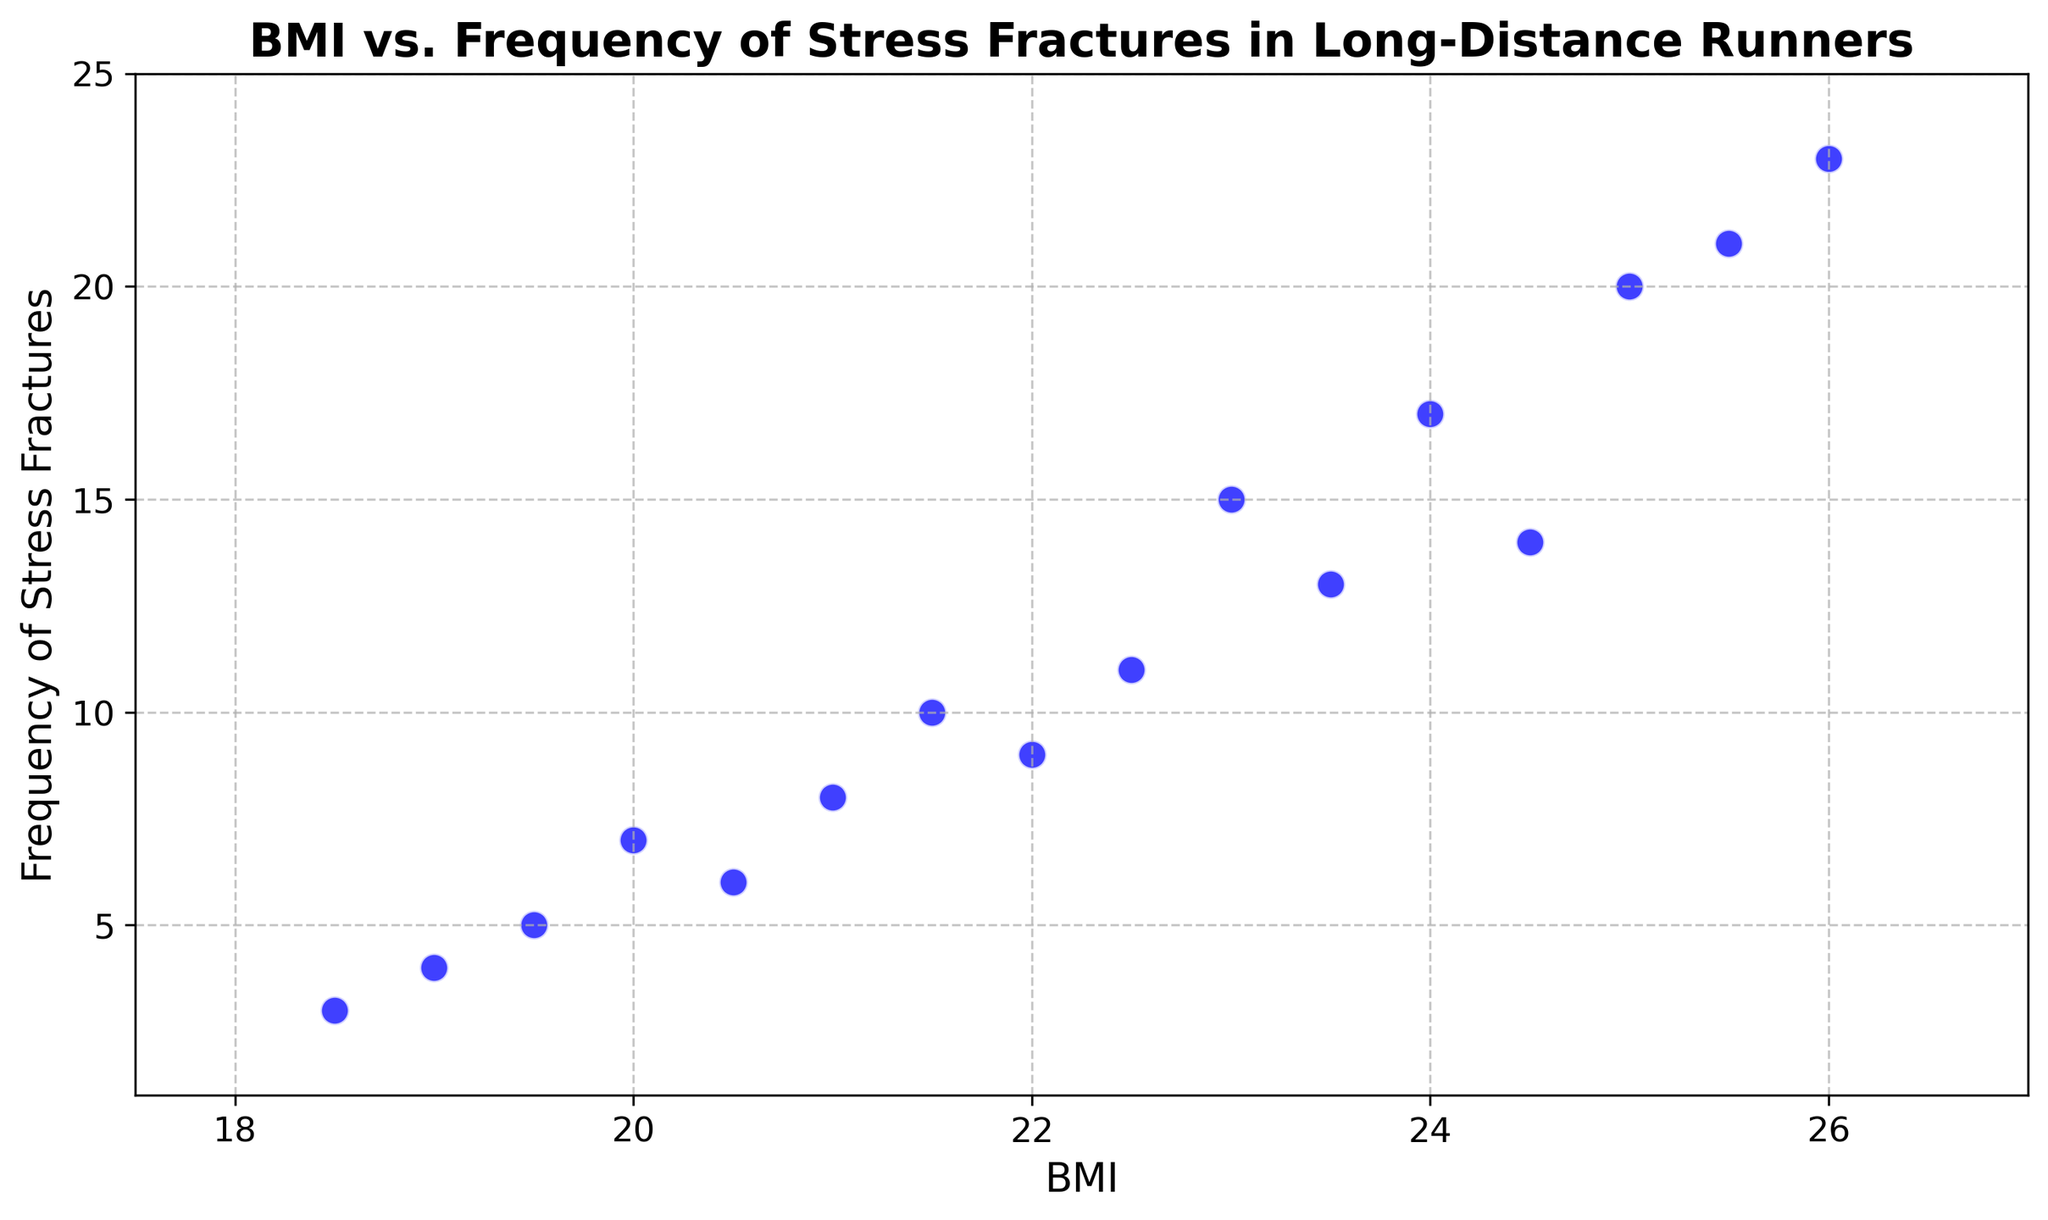What range of BMI values does the figure cover? The x-axis, labeled "BMI," shows values starting at 17.5 and ending at 27, which indicates the range of BMI values covered in the scatter plot.
Answer: 17.5 to 27 At what BMI is the frequency of stress fractures highest? By examining where the scatter points reach their maximum vertical position on the y-axis, labeled "Frequency of Stress Fractures," it can be seen that the highest frequency of stress fractures occurs at a BMI of 26 with a frequency of 23.
Answer: 26 How does the frequency of stress fractures change as BMI increases from 18.5 to 25.5? By following the scatter points from a BMI of 18.5 to 25.5 on the x-axis and noting the y-values, it can be observed that the frequency of stress fractures generally increases as BMI increases, with some fluctuations.
Answer: It generally increases What is the average frequency of stress fractures for BMIs between 20 and 22 (inclusive)? The points for BMIs 20, 20.5, 21, and 22 show frequencies of 7, 6, 8, and 9 respectively. Adding these values gives 7 + 6 + 8 + 9 = 30. There are 4 data points, so the average is 30/4 = 7.5.
Answer: 7.5 Is there any notable trend in the relationship between BMI and stress fractures? By observing the pattern of scatter points from left to right across the figure, it can be noted that as BMI increases, the frequency of stress fractures generally increases, suggesting a positive correlation.
Answer: Positive correlation Which BMI has the least frequency of stress fractures, and what is its value? The scatter point with the lowest position on the y-axis corresponds to the BMI of 18.5, which has a value of 3.
Answer: 18.5, 3 What is the total frequency of stress fractures for BMIs above 24 inclusive? For BMIs 24, 24.5, 25, 25.5, and 26, the frequencies are 17, 14, 20, 21, and 23 respectively. Adding these values gives 17 + 14 + 20 + 21 + 23 = 95.
Answer: 95 Compare the difference in stress fracture frequency between the lowest and highest BMI values. The frequency for the lowest BMI (18.5) is 3, while for the highest BMI (26) is 23. The difference in frequency is 23 - 3 = 20.
Answer: 20 What can you infer about BMIs around 22.5 and their associated stress fracture frequency? The scatter point at BMI 22.5 indicates a stress fracture frequency of 11, which is relatively high compared to other points, suggesting a higher risk of stress fractures around this BMI.
Answer: Relatively high frequency of 11 Do any BMIs have the same frequency of stress fractures? By scanning the scatter points, it can be observed that no two BMI values have the same frequency of stress fractures in this dataset.
Answer: No 